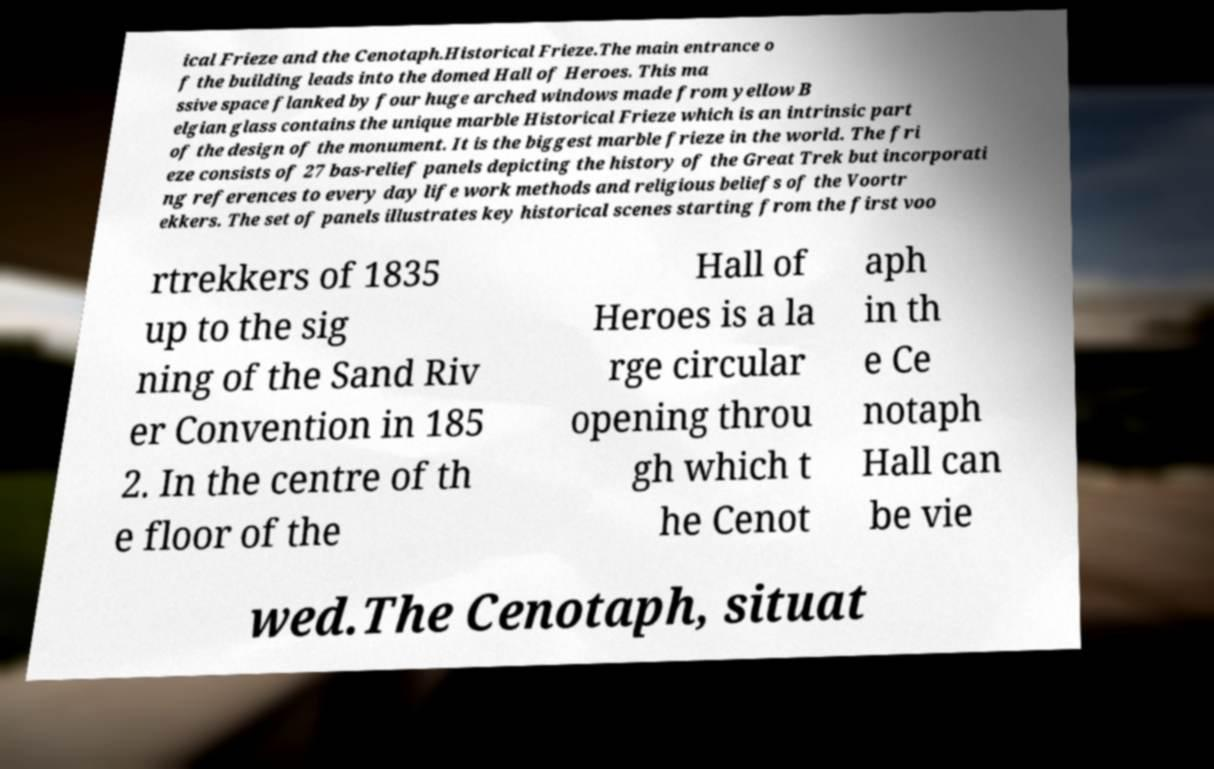Please identify and transcribe the text found in this image. ical Frieze and the Cenotaph.Historical Frieze.The main entrance o f the building leads into the domed Hall of Heroes. This ma ssive space flanked by four huge arched windows made from yellow B elgian glass contains the unique marble Historical Frieze which is an intrinsic part of the design of the monument. It is the biggest marble frieze in the world. The fri eze consists of 27 bas-relief panels depicting the history of the Great Trek but incorporati ng references to every day life work methods and religious beliefs of the Voortr ekkers. The set of panels illustrates key historical scenes starting from the first voo rtrekkers of 1835 up to the sig ning of the Sand Riv er Convention in 185 2. In the centre of th e floor of the Hall of Heroes is a la rge circular opening throu gh which t he Cenot aph in th e Ce notaph Hall can be vie wed.The Cenotaph, situat 